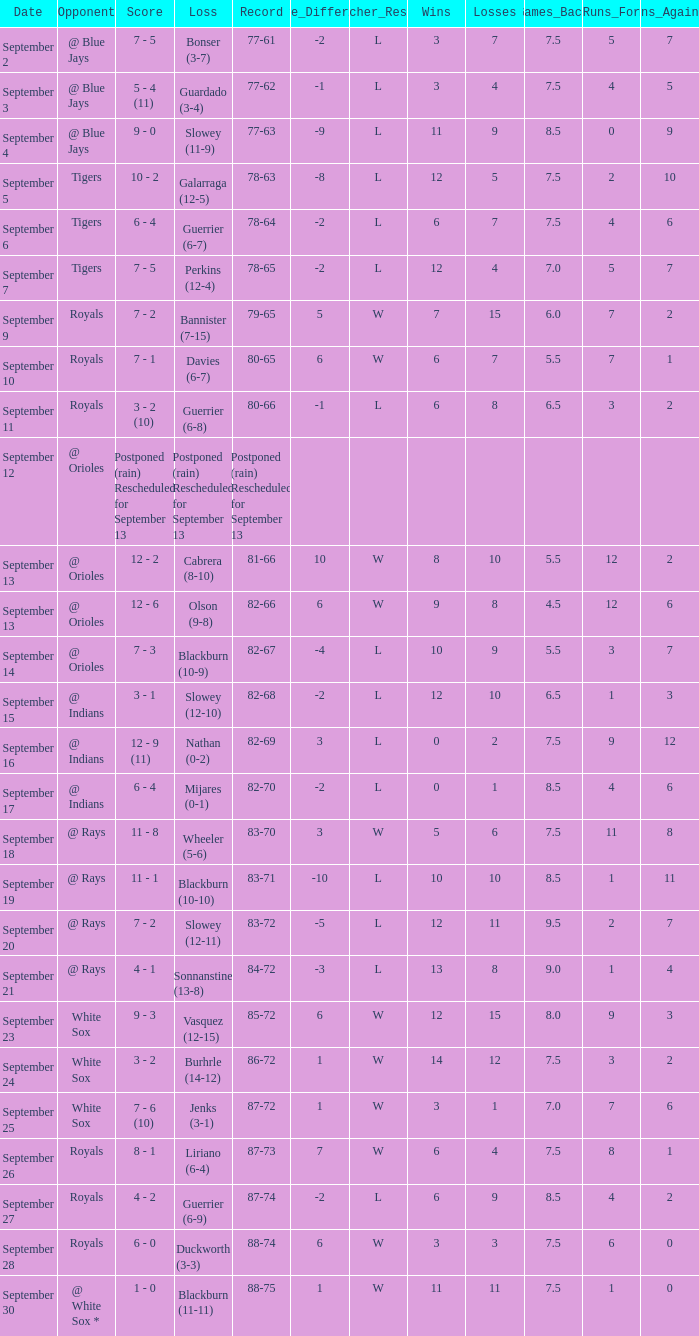What opponent has the record of 78-63? Tigers. 